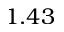Convert formula to latex. <formula><loc_0><loc_0><loc_500><loc_500>1 . 4 3</formula> 